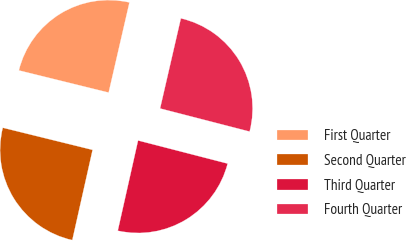Convert chart to OTSL. <chart><loc_0><loc_0><loc_500><loc_500><pie_chart><fcel>First Quarter<fcel>Second Quarter<fcel>Third Quarter<fcel>Fourth Quarter<nl><fcel>24.76%<fcel>25.33%<fcel>24.5%<fcel>25.41%<nl></chart> 